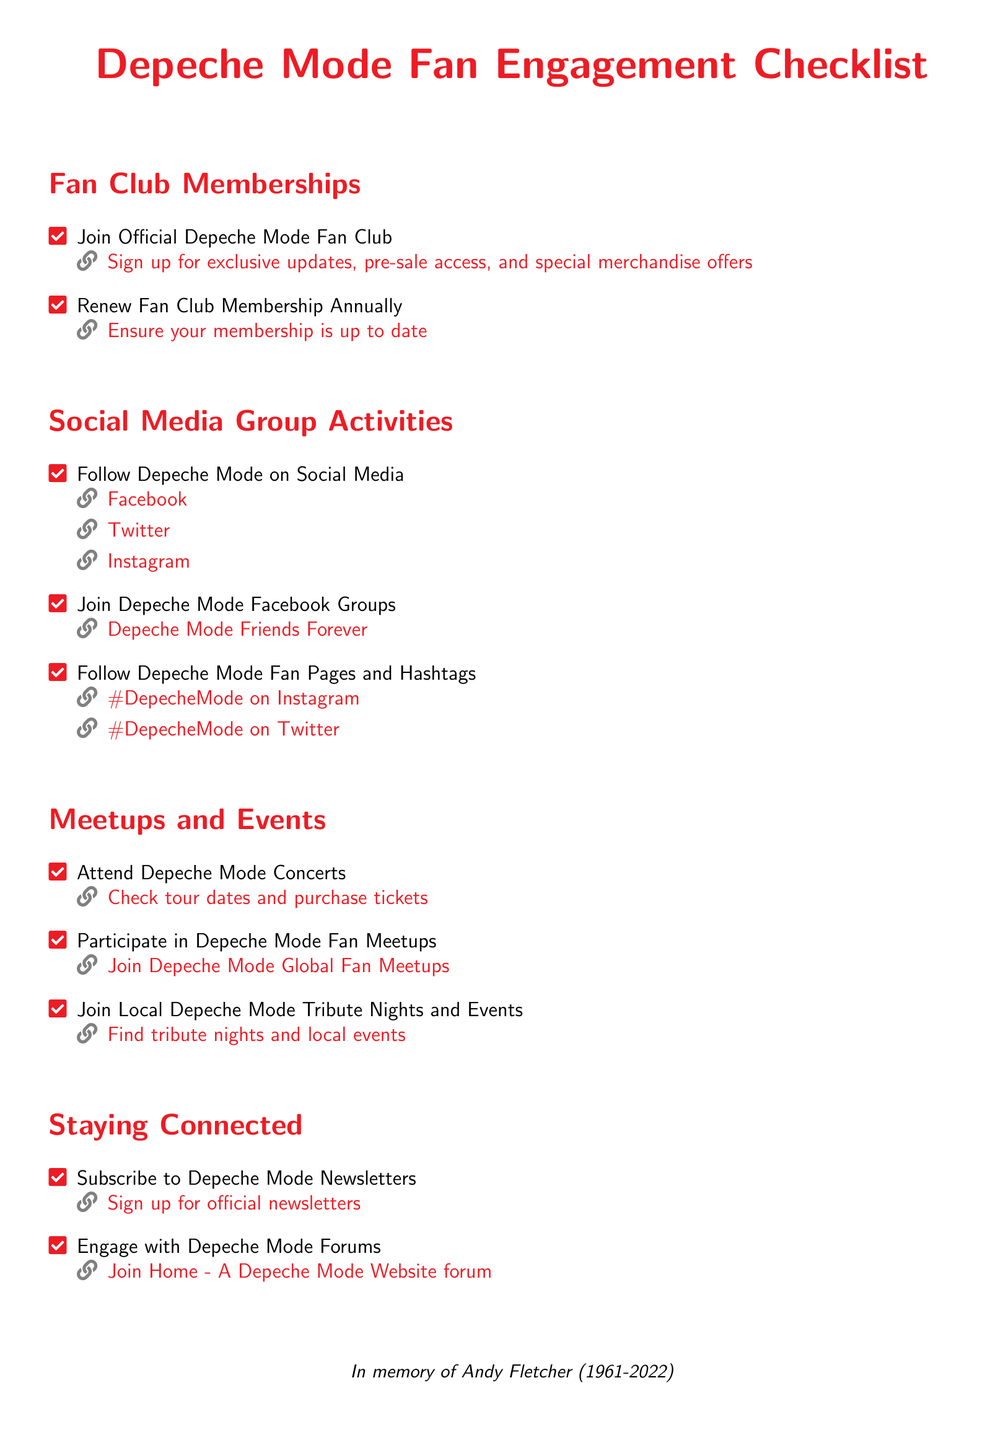What is the title of the document? The title of the document is prominently displayed at the top as "Depeche Mode Fan Engagement Checklist."
Answer: Depeche Mode Fan Engagement Checklist What are the two sections listed under Fan Club Memberships? The sections include joining the fan club and renewing the membership annually.
Answer: Join Official Depeche Mode Fan Club, Renew Fan Club Membership Annually How many social media platforms are mentioned to follow Depeche Mode? The checklist lists three social media platforms for following Depeche Mode.
Answer: Three What is the link to check tour dates? The document provides a specific hyperlink for checking tour dates and purchasing tickets.
Answer: https://www.depechemode.com/tour What is recommended for staying updated with Depeche Mode news? The checklist encourages subscribing to newsletters to stay updated.
Answer: Subscribe to Depeche Mode Newsletters What kind of events can fans participate in aside from concerts? The document mentions local tribute nights and fan meetups as events fans can join.
Answer: Local Depeche Mode Tribute Nights and Events How is the checklist concluded? The checklist concludes with a tribute to Andy Fletcher, marking his memory.
Answer: In memory of Andy Fletcher (1961-2022) What is one Facebook group mentioned for Depeche Mode fans? The checklist references a specific Facebook group for fans to join.
Answer: Depeche Mode Friends Forever 